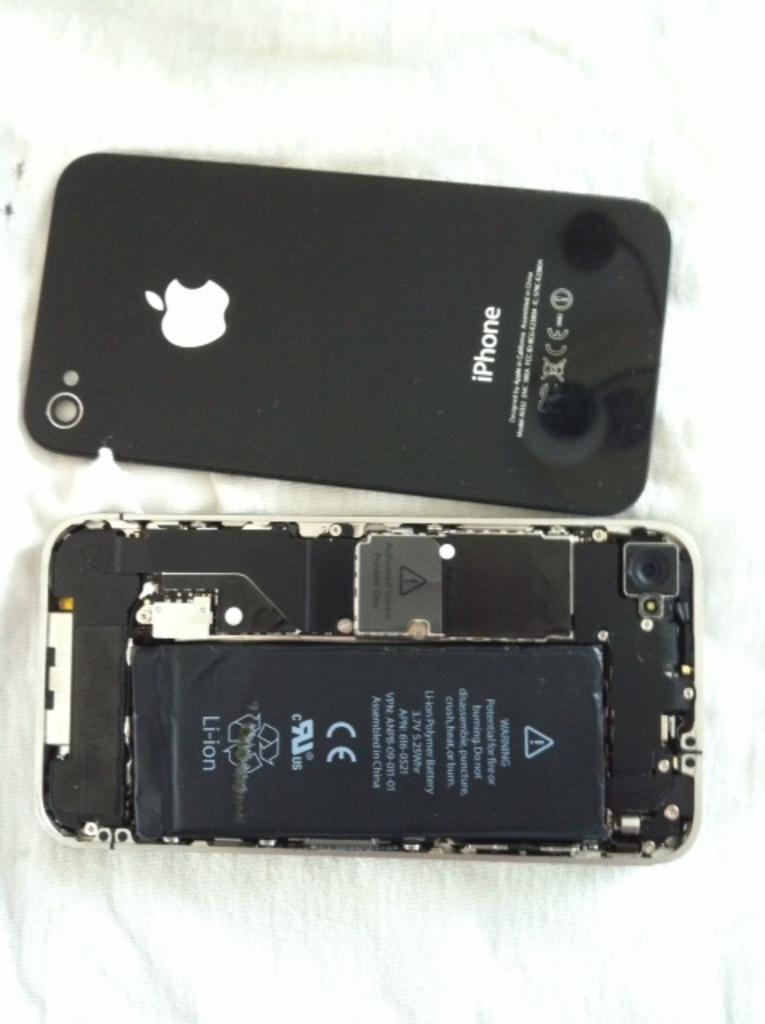<image>
Offer a succinct explanation of the picture presented. A black iPhone with the back taken off revealing the Li-ion battery. 